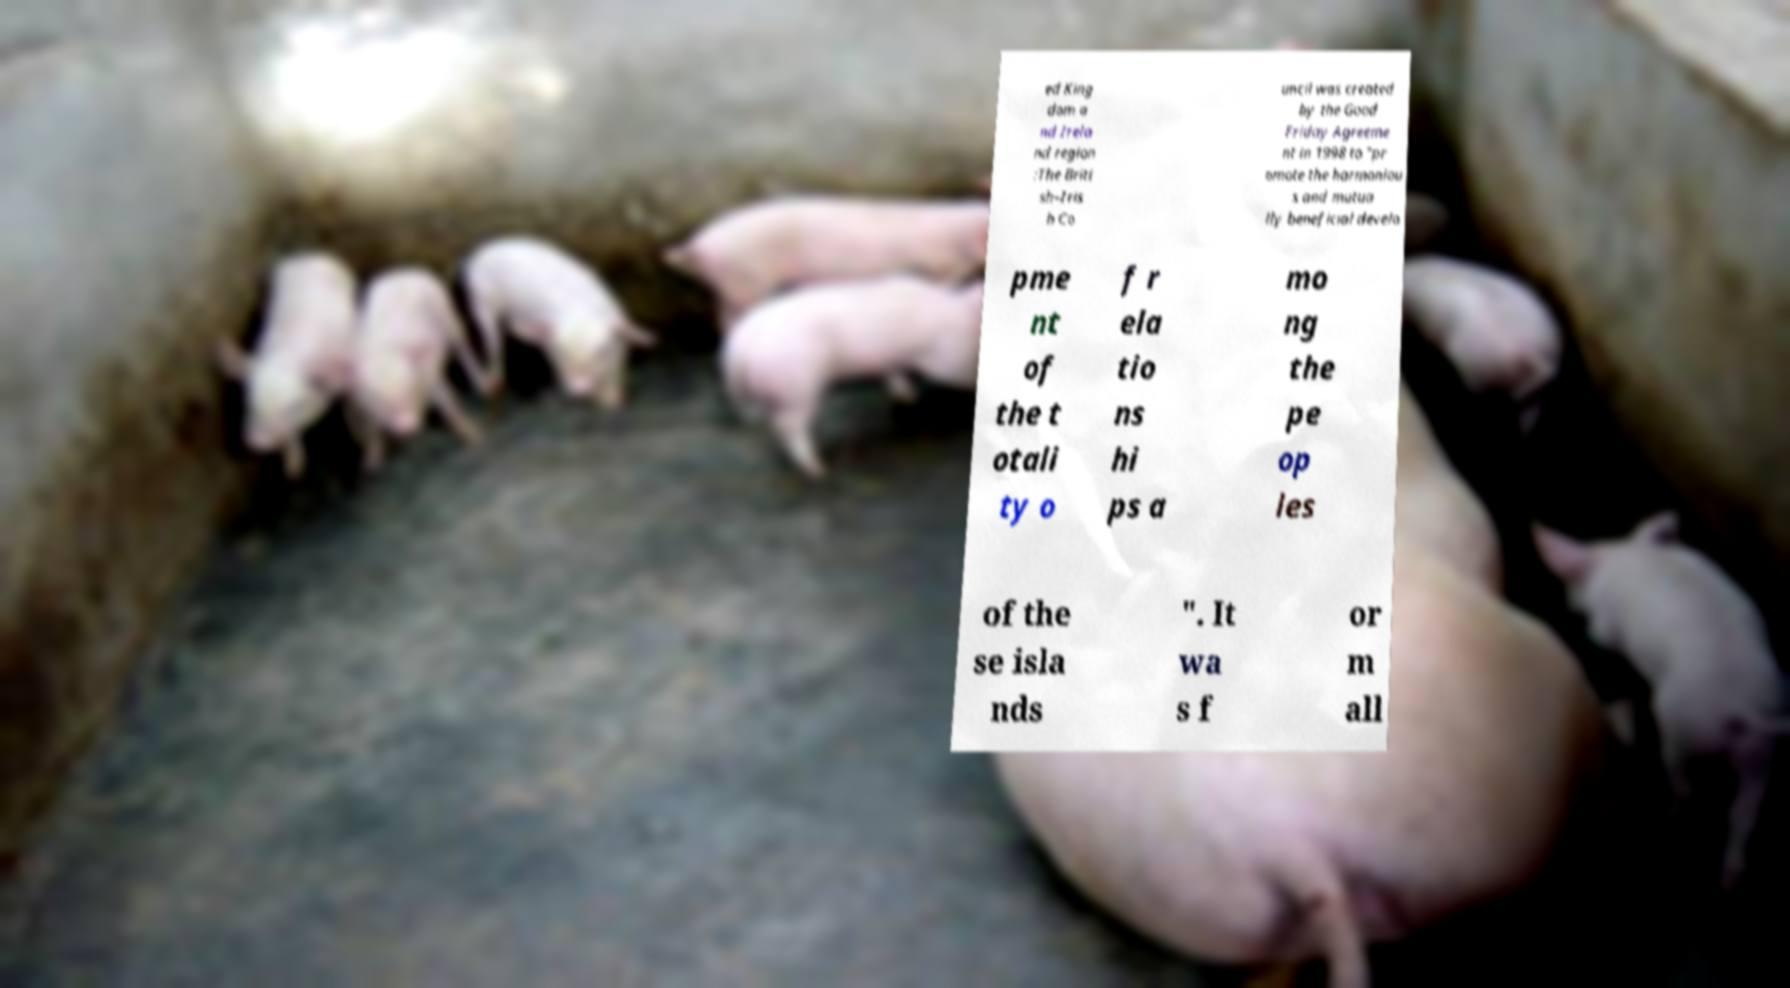There's text embedded in this image that I need extracted. Can you transcribe it verbatim? ed King dom a nd Irela nd region :The Briti sh–Iris h Co uncil was created by the Good Friday Agreeme nt in 1998 to "pr omote the harmoniou s and mutua lly beneficial develo pme nt of the t otali ty o f r ela tio ns hi ps a mo ng the pe op les of the se isla nds ". It wa s f or m all 